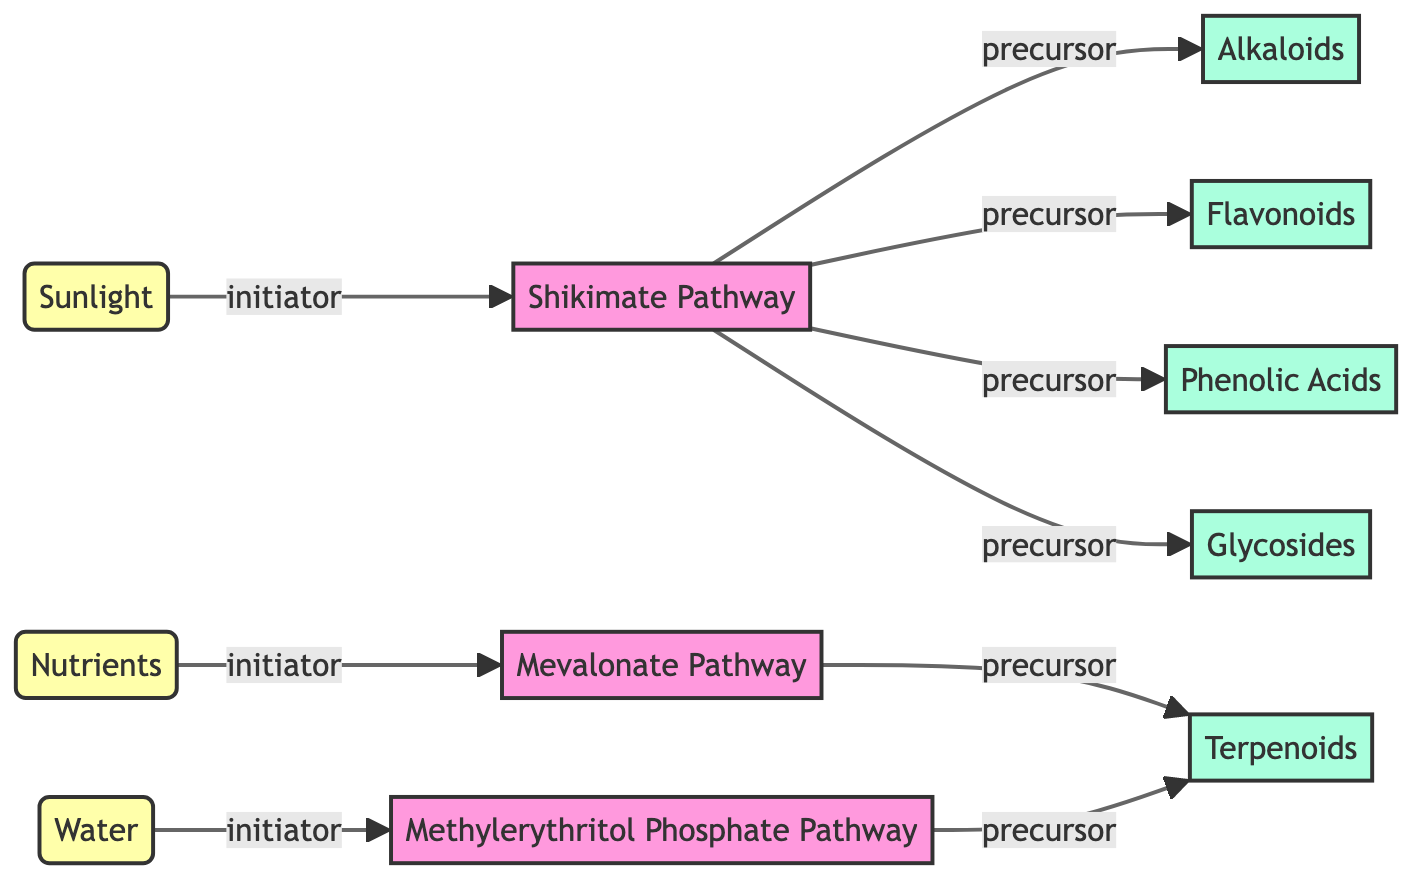What are the three initiators in the diagram? The diagram shows three initiators connected to pathways: Sunlight, Nutrients, and Water. Each initiator is labeled distinctly and points towards a specific pathway.
Answer: Sunlight, Nutrients, Water How many metabolites are shown in the diagram? By counting the nodes labeled as metabolites, we find Alkaloids, Flavonoids, Terpenoids, Phenolic Acids, and Glycosides, resulting in a total of five metabolites.
Answer: 5 Which pathway is connected to Glycosides? Glycosides is connected to the Shikimate Pathway, as indicated by the edge labeled as "precursor" connecting these two nodes.
Answer: Shikimate Pathway What is the relationship between the Mevalonate Pathway and Terpenoids? The Mevalonate Pathway has a "precursor" relationship with Terpenoids, which means that the Mevalonate Pathway leads to the production of Terpenoids in the network diagram.
Answer: precursor What initiates the Shikimate Pathway? The diagram shows that the Shikimate Pathway is initiated by Sunlight, indicated by the directed edge labeled "initiator" leading from Sunlight to the Shikimate Pathway.
Answer: Sunlight Which pathways produce Terpenoids? Terpenoids are produced through two pathways: the Mevalonate Pathway and the Methylerythritol Phosphate Pathway, as both are connected to Terpenoids via the "precursor" edge.
Answer: Mevalonate Pathway, Methylerythritol Phosphate Pathway What type of diagram is represented in the illustration? The diagram is a Network Diagram, which visually represents the relationships between the initiators, pathways, and metabolites in the production of secondary metabolites in medicinal plants.
Answer: Network Diagram How many edges are in the diagram? By counting the relationships (edges) in the diagram, we find a total of eight edges that connect the nodes according to their relationships as indicated in the data structure.
Answer: 8 